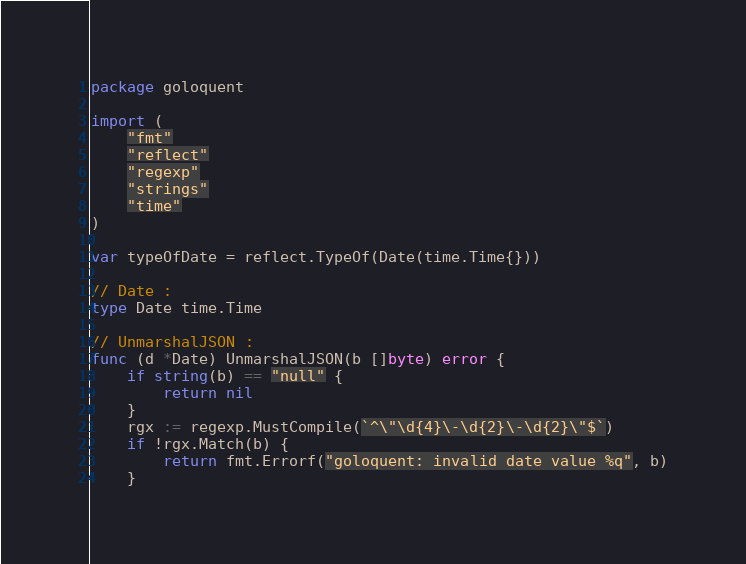<code> <loc_0><loc_0><loc_500><loc_500><_Go_>package goloquent

import (
	"fmt"
	"reflect"
	"regexp"
	"strings"
	"time"
)

var typeOfDate = reflect.TypeOf(Date(time.Time{}))

// Date :
type Date time.Time

// UnmarshalJSON :
func (d *Date) UnmarshalJSON(b []byte) error {
	if string(b) == "null" {
		return nil
	}
	rgx := regexp.MustCompile(`^\"\d{4}\-\d{2}\-\d{2}\"$`)
	if !rgx.Match(b) {
		return fmt.Errorf("goloquent: invalid date value %q", b)
	}</code> 